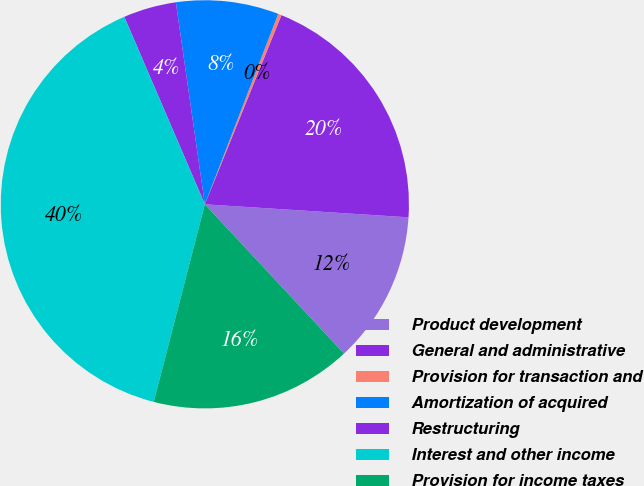Convert chart. <chart><loc_0><loc_0><loc_500><loc_500><pie_chart><fcel>Product development<fcel>General and administrative<fcel>Provision for transaction and<fcel>Amortization of acquired<fcel>Restructuring<fcel>Interest and other income<fcel>Provision for income taxes<nl><fcel>12.04%<fcel>19.89%<fcel>0.27%<fcel>8.12%<fcel>4.19%<fcel>39.51%<fcel>15.97%<nl></chart> 